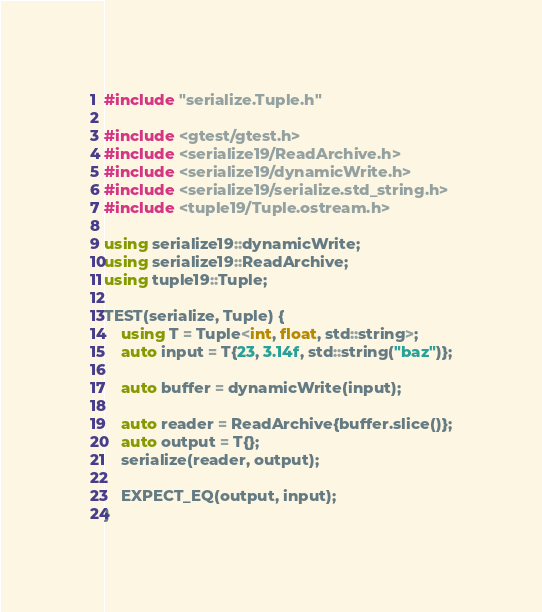Convert code to text. <code><loc_0><loc_0><loc_500><loc_500><_C++_>#include "serialize.Tuple.h"

#include <gtest/gtest.h>
#include <serialize19/ReadArchive.h>
#include <serialize19/dynamicWrite.h>
#include <serialize19/serialize.std_string.h>
#include <tuple19/Tuple.ostream.h>

using serialize19::dynamicWrite;
using serialize19::ReadArchive;
using tuple19::Tuple;

TEST(serialize, Tuple) {
    using T = Tuple<int, float, std::string>;
    auto input = T{23, 3.14f, std::string("baz")};

    auto buffer = dynamicWrite(input);

    auto reader = ReadArchive{buffer.slice()};
    auto output = T{};
    serialize(reader, output);

    EXPECT_EQ(output, input);
}
</code> 